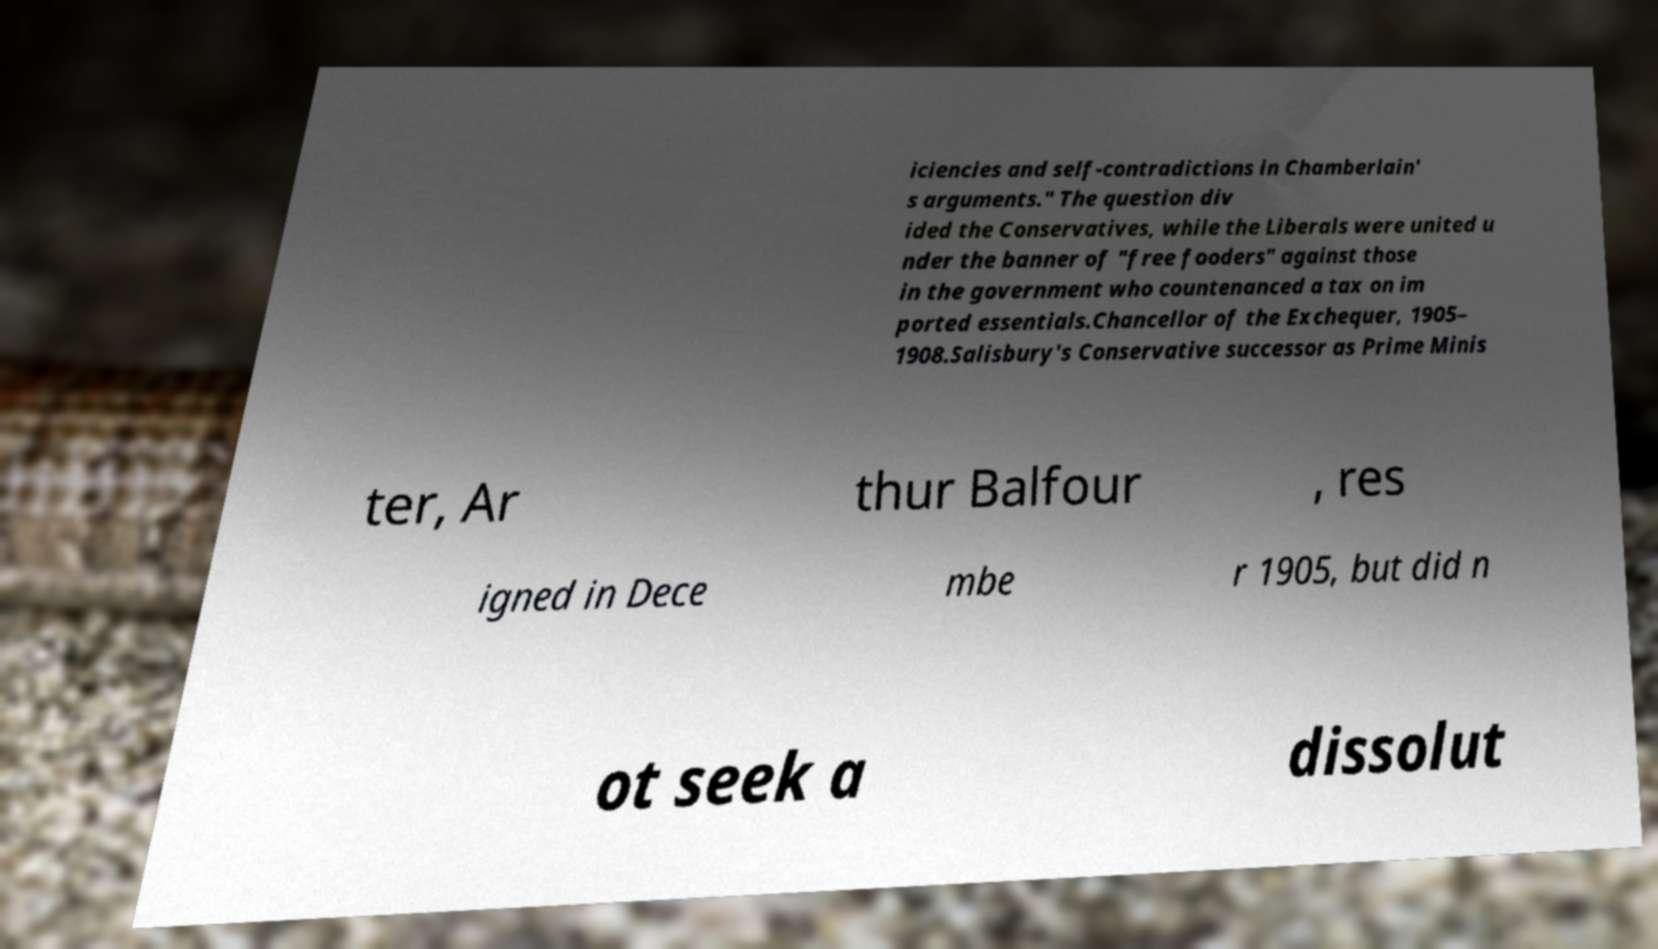Could you extract and type out the text from this image? iciencies and self-contradictions in Chamberlain' s arguments." The question div ided the Conservatives, while the Liberals were united u nder the banner of "free fooders" against those in the government who countenanced a tax on im ported essentials.Chancellor of the Exchequer, 1905– 1908.Salisbury's Conservative successor as Prime Minis ter, Ar thur Balfour , res igned in Dece mbe r 1905, but did n ot seek a dissolut 